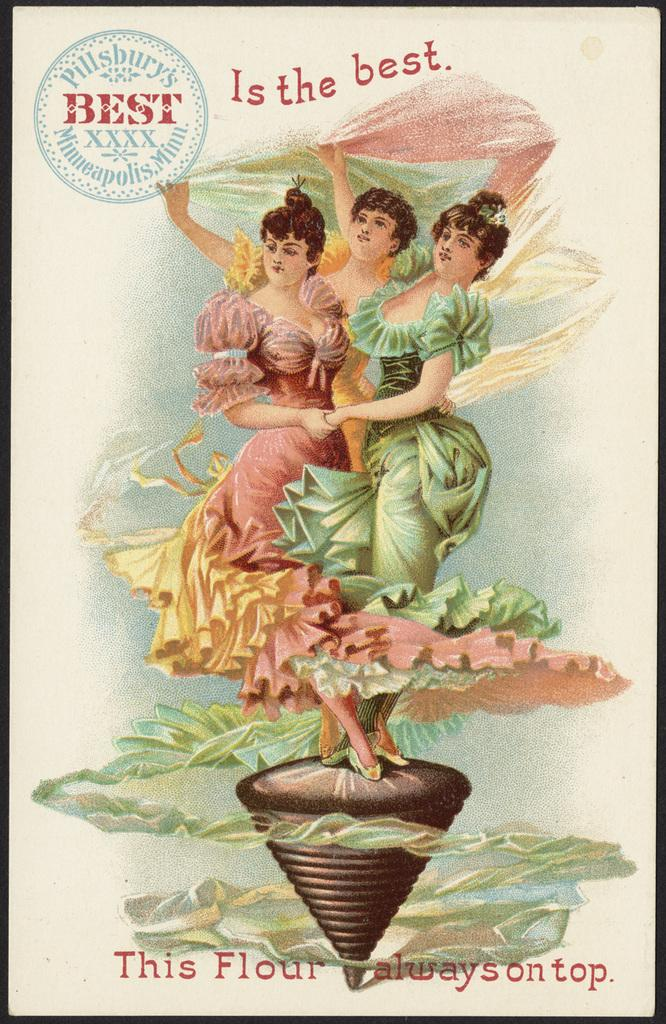Provide a one-sentence caption for the provided image. Three women in a poster that reads "Is the best.". 